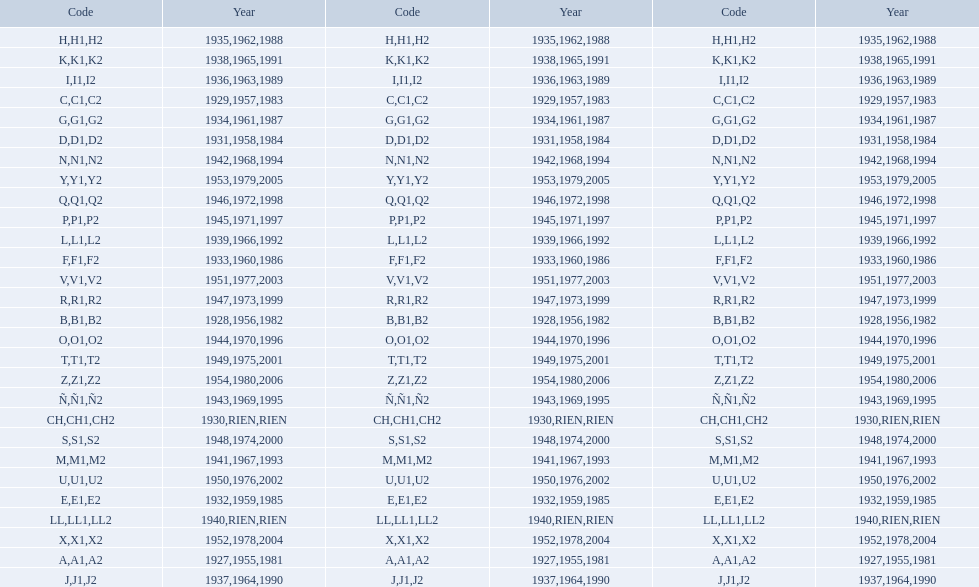Number of codes containing a 2? 28. 